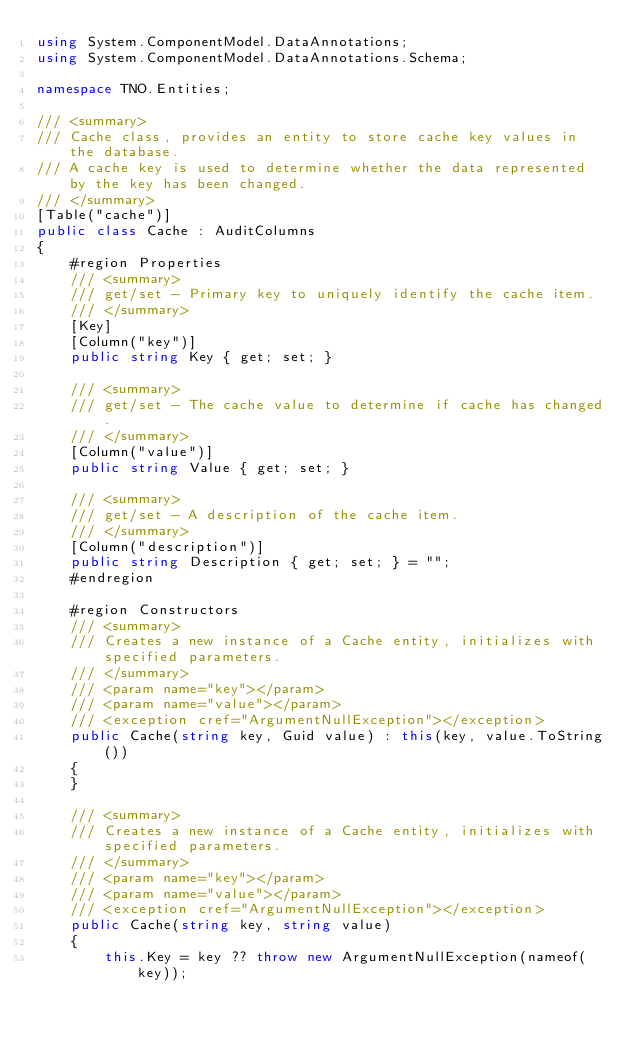<code> <loc_0><loc_0><loc_500><loc_500><_C#_>using System.ComponentModel.DataAnnotations;
using System.ComponentModel.DataAnnotations.Schema;

namespace TNO.Entities;

/// <summary>
/// Cache class, provides an entity to store cache key values in the database.
/// A cache key is used to determine whether the data represented by the key has been changed.
/// </summary>
[Table("cache")]
public class Cache : AuditColumns
{
    #region Properties
    /// <summary>
    /// get/set - Primary key to uniquely identify the cache item.
    /// </summary>
    [Key]
    [Column("key")]
    public string Key { get; set; }

    /// <summary>
    /// get/set - The cache value to determine if cache has changed.
    /// </summary>
    [Column("value")]
    public string Value { get; set; }

    /// <summary>
    /// get/set - A description of the cache item.
    /// </summary>
    [Column("description")]
    public string Description { get; set; } = "";
    #endregion

    #region Constructors
    /// <summary>
    /// Creates a new instance of a Cache entity, initializes with specified parameters.
    /// </summary>
    /// <param name="key"></param>
    /// <param name="value"></param>
    /// <exception cref="ArgumentNullException"></exception>
    public Cache(string key, Guid value) : this(key, value.ToString())
    {
    }

    /// <summary>
    /// Creates a new instance of a Cache entity, initializes with specified parameters.
    /// </summary>
    /// <param name="key"></param>
    /// <param name="value"></param>
    /// <exception cref="ArgumentNullException"></exception>
    public Cache(string key, string value)
    {
        this.Key = key ?? throw new ArgumentNullException(nameof(key));</code> 